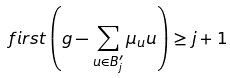Convert formula to latex. <formula><loc_0><loc_0><loc_500><loc_500>\ f i r s t \left ( g - \sum _ { u \in B _ { j } ^ { \prime } } \mu _ { u } u \right ) \geq j + 1</formula> 